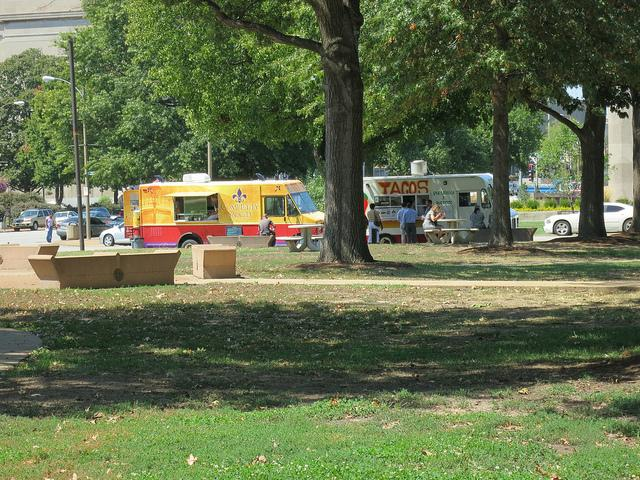What is the yellow truck doing? Please explain your reasoning. selling food. It's a food truck and it's there making and selling food. 